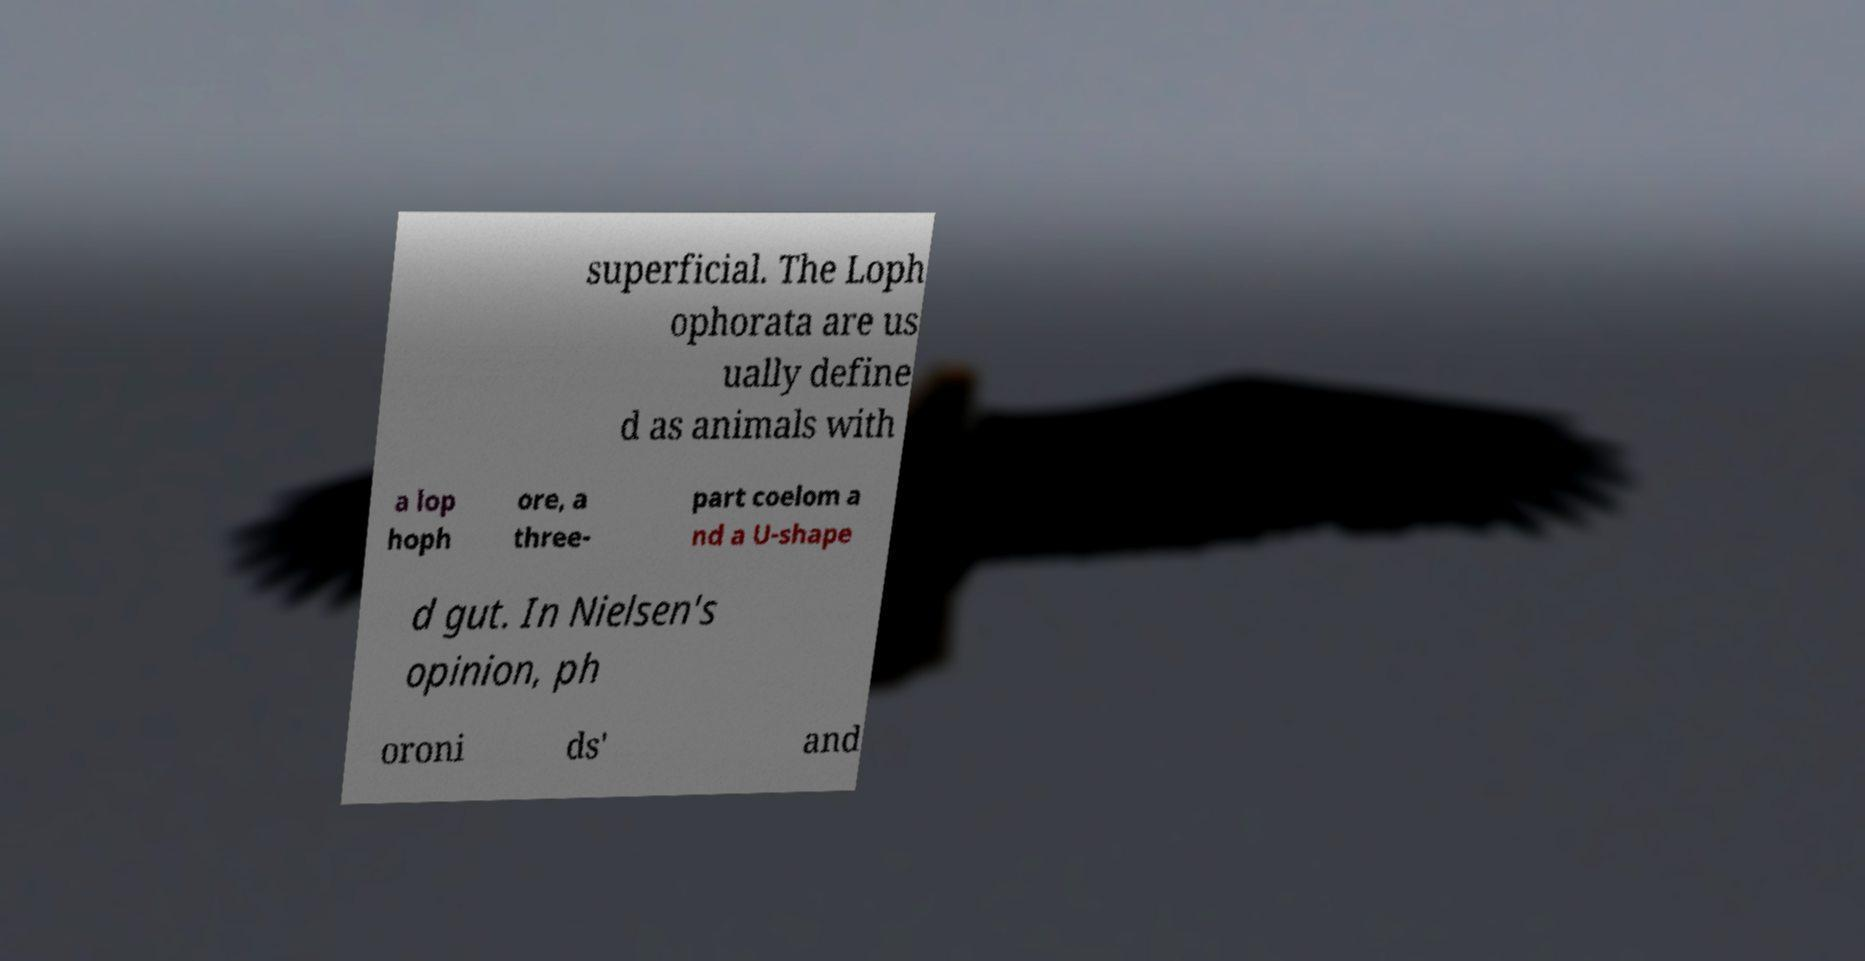Please read and relay the text visible in this image. What does it say? superficial. The Loph ophorata are us ually define d as animals with a lop hoph ore, a three- part coelom a nd a U-shape d gut. In Nielsen's opinion, ph oroni ds' and 